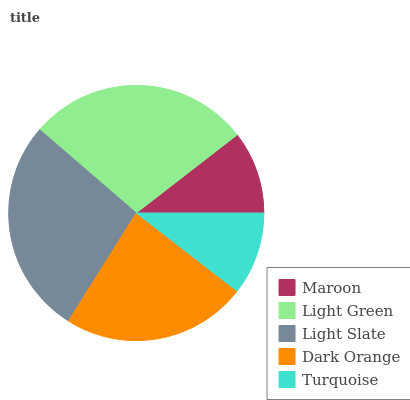Is Turquoise the minimum?
Answer yes or no. Yes. Is Light Green the maximum?
Answer yes or no. Yes. Is Light Slate the minimum?
Answer yes or no. No. Is Light Slate the maximum?
Answer yes or no. No. Is Light Green greater than Light Slate?
Answer yes or no. Yes. Is Light Slate less than Light Green?
Answer yes or no. Yes. Is Light Slate greater than Light Green?
Answer yes or no. No. Is Light Green less than Light Slate?
Answer yes or no. No. Is Dark Orange the high median?
Answer yes or no. Yes. Is Dark Orange the low median?
Answer yes or no. Yes. Is Maroon the high median?
Answer yes or no. No. Is Maroon the low median?
Answer yes or no. No. 